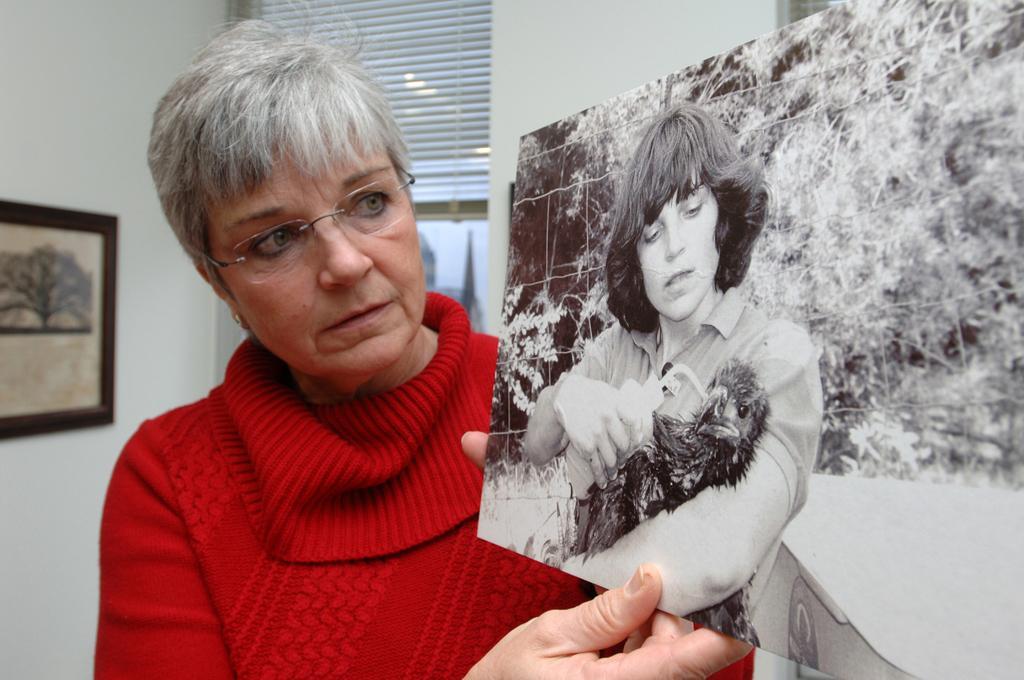How would you summarize this image in a sentence or two? In this picture we can see a person holding a photograph and in the background we can see a wall, photo frame and some objects. 